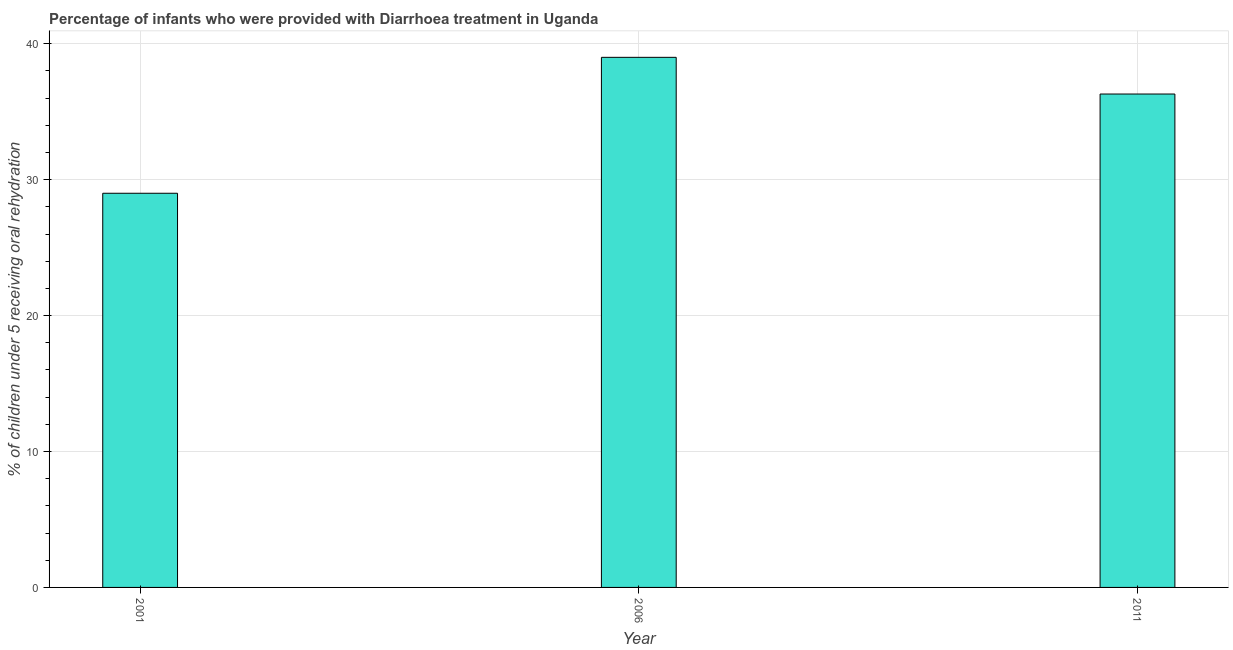Does the graph contain any zero values?
Your response must be concise. No. What is the title of the graph?
Give a very brief answer. Percentage of infants who were provided with Diarrhoea treatment in Uganda. What is the label or title of the Y-axis?
Provide a short and direct response. % of children under 5 receiving oral rehydration. What is the percentage of children who were provided with treatment diarrhoea in 2006?
Offer a very short reply. 39. Across all years, what is the maximum percentage of children who were provided with treatment diarrhoea?
Provide a short and direct response. 39. What is the sum of the percentage of children who were provided with treatment diarrhoea?
Make the answer very short. 104.3. What is the average percentage of children who were provided with treatment diarrhoea per year?
Give a very brief answer. 34.77. What is the median percentage of children who were provided with treatment diarrhoea?
Make the answer very short. 36.3. In how many years, is the percentage of children who were provided with treatment diarrhoea greater than 4 %?
Your response must be concise. 3. Do a majority of the years between 2006 and 2011 (inclusive) have percentage of children who were provided with treatment diarrhoea greater than 18 %?
Keep it short and to the point. Yes. What is the ratio of the percentage of children who were provided with treatment diarrhoea in 2001 to that in 2006?
Offer a very short reply. 0.74. Is the difference between the percentage of children who were provided with treatment diarrhoea in 2001 and 2006 greater than the difference between any two years?
Provide a short and direct response. Yes. What is the difference between the highest and the second highest percentage of children who were provided with treatment diarrhoea?
Keep it short and to the point. 2.7. What is the difference between the highest and the lowest percentage of children who were provided with treatment diarrhoea?
Your response must be concise. 10. In how many years, is the percentage of children who were provided with treatment diarrhoea greater than the average percentage of children who were provided with treatment diarrhoea taken over all years?
Offer a terse response. 2. How many bars are there?
Provide a succinct answer. 3. Are all the bars in the graph horizontal?
Keep it short and to the point. No. What is the difference between two consecutive major ticks on the Y-axis?
Ensure brevity in your answer.  10. What is the % of children under 5 receiving oral rehydration in 2011?
Keep it short and to the point. 36.3. What is the difference between the % of children under 5 receiving oral rehydration in 2001 and 2006?
Keep it short and to the point. -10. What is the ratio of the % of children under 5 receiving oral rehydration in 2001 to that in 2006?
Give a very brief answer. 0.74. What is the ratio of the % of children under 5 receiving oral rehydration in 2001 to that in 2011?
Offer a very short reply. 0.8. What is the ratio of the % of children under 5 receiving oral rehydration in 2006 to that in 2011?
Your answer should be compact. 1.07. 